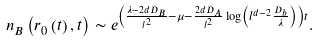Convert formula to latex. <formula><loc_0><loc_0><loc_500><loc_500>n _ { B } \left ( r _ { 0 } \left ( t \right ) , t \right ) \sim e ^ { \left ( \frac { \lambda - 2 d D _ { B } } { l ^ { 2 } } - \mu - \frac { 2 d D _ { A } } { l ^ { 2 } } \log \left ( l ^ { d - 2 } \frac { D _ { b } } { \lambda } \right ) \right ) t } .</formula> 